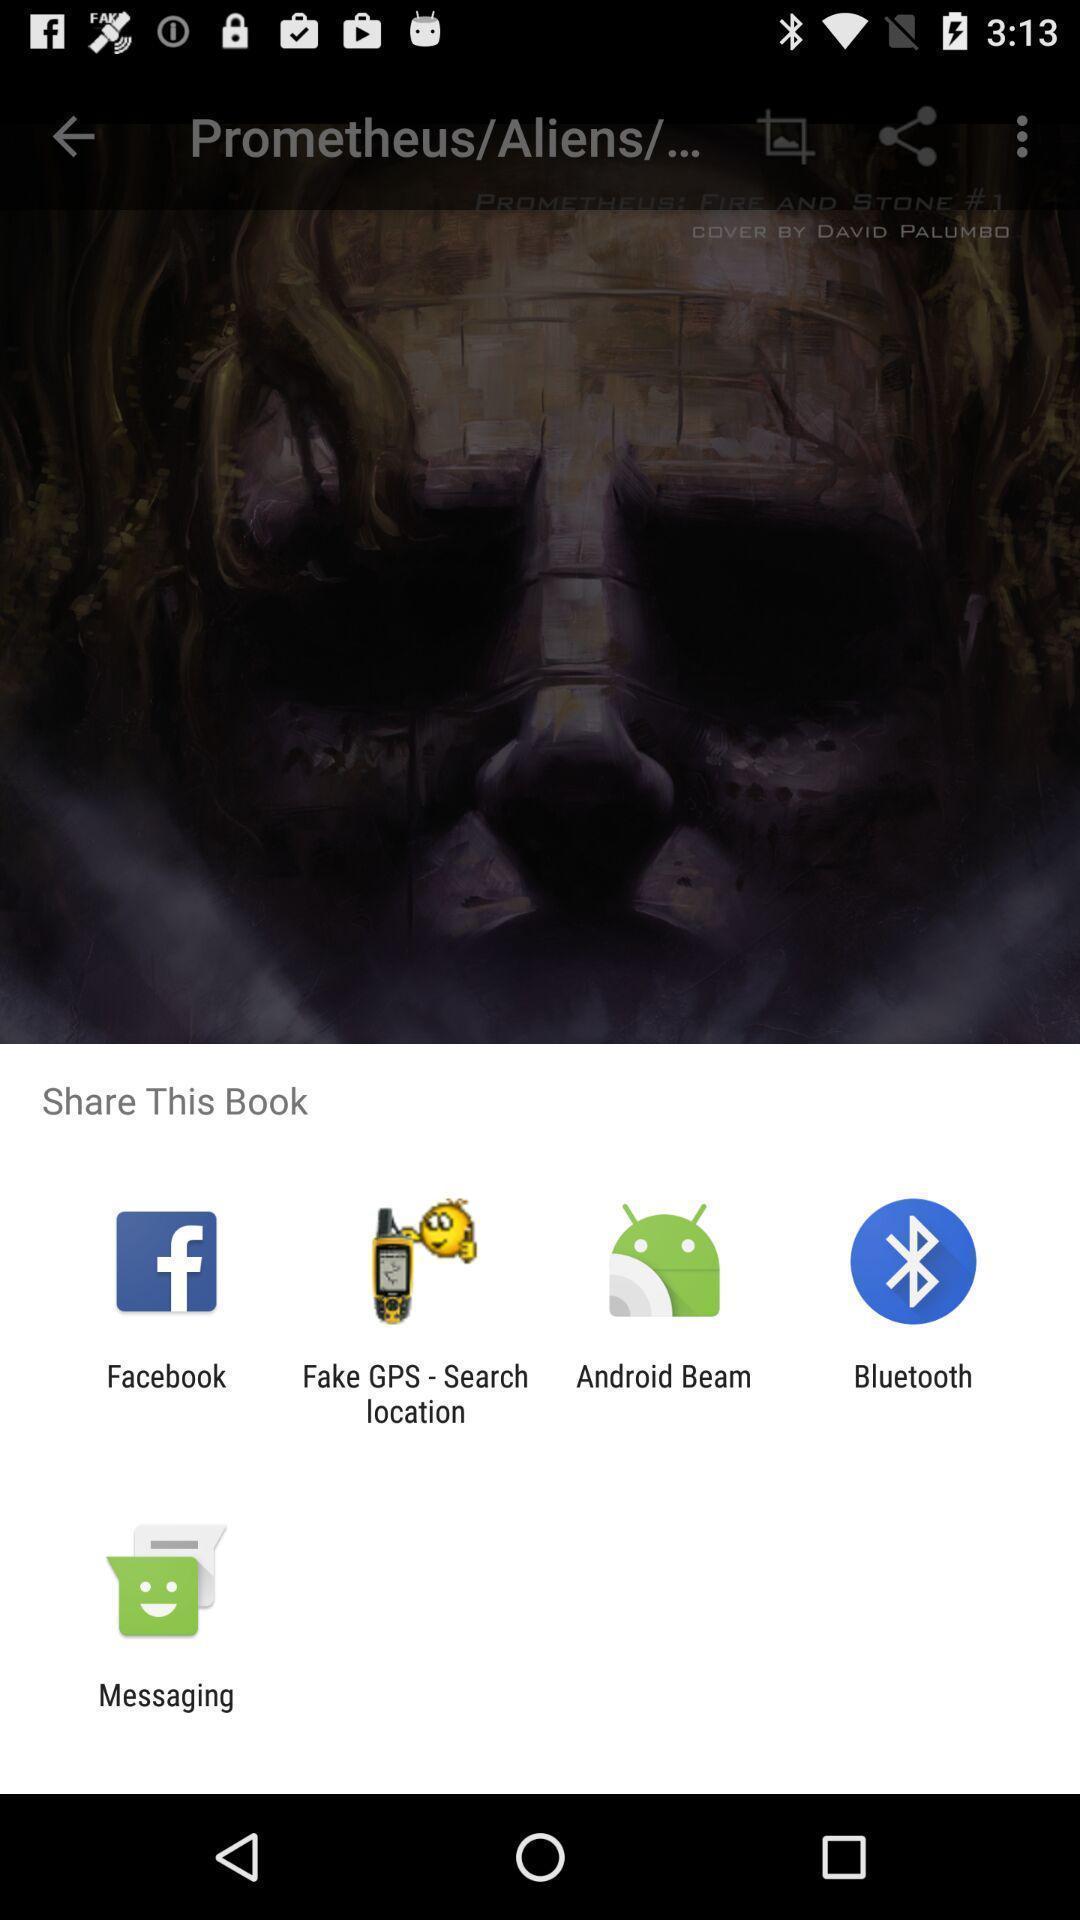What details can you identify in this image? Push up message for sharing data via social network. 